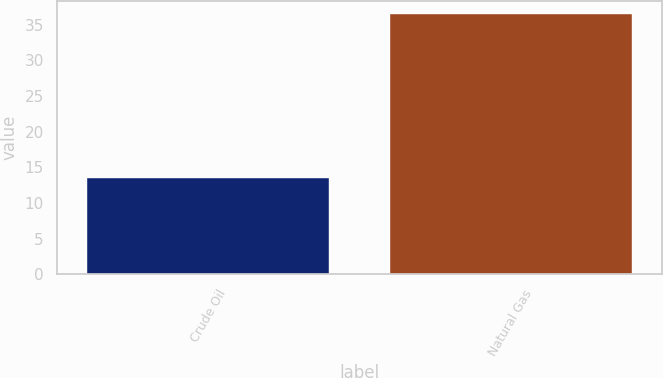<chart> <loc_0><loc_0><loc_500><loc_500><bar_chart><fcel>Crude Oil<fcel>Natural Gas<nl><fcel>13.5<fcel>36.5<nl></chart> 